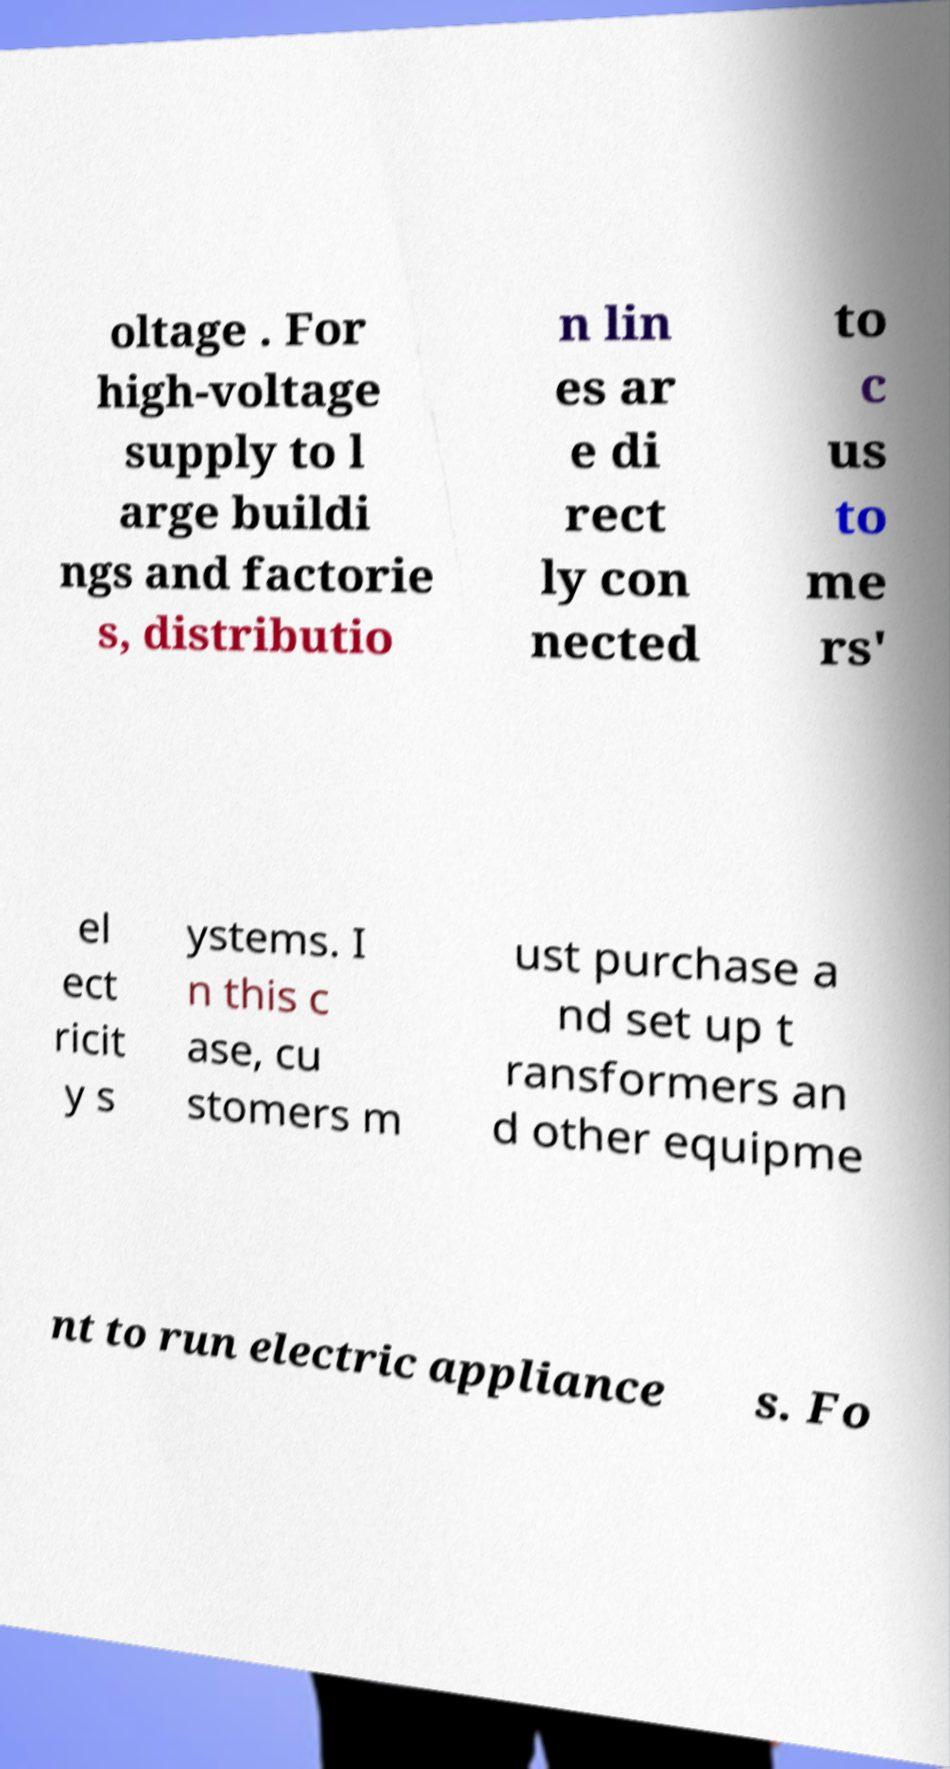Could you extract and type out the text from this image? oltage . For high-voltage supply to l arge buildi ngs and factorie s, distributio n lin es ar e di rect ly con nected to c us to me rs' el ect ricit y s ystems. I n this c ase, cu stomers m ust purchase a nd set up t ransformers an d other equipme nt to run electric appliance s. Fo 